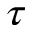<formula> <loc_0><loc_0><loc_500><loc_500>\tau</formula> 